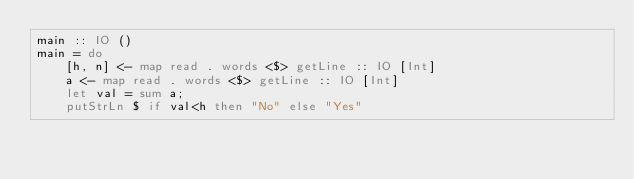<code> <loc_0><loc_0><loc_500><loc_500><_Haskell_>main :: IO ()
main = do
    [h, n] <- map read . words <$> getLine :: IO [Int]
    a <- map read . words <$> getLine :: IO [Int]
    let val = sum a;
    putStrLn $ if val<h then "No" else "Yes" 
</code> 